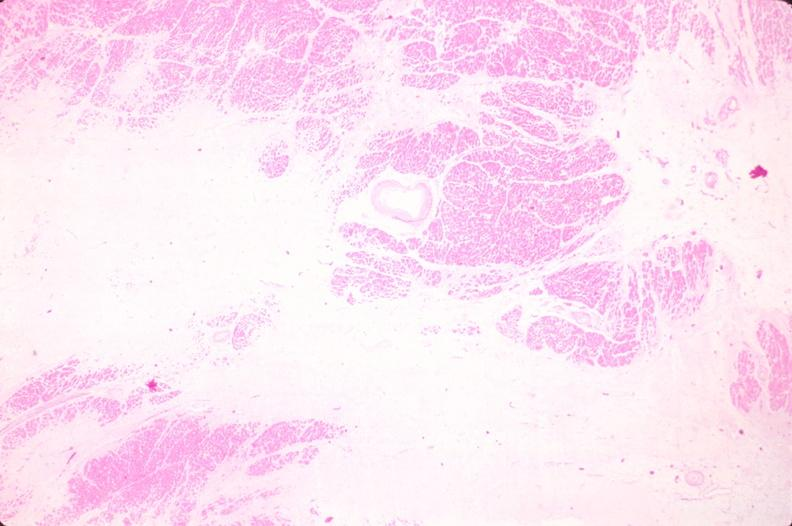s cachexia present?
Answer the question using a single word or phrase. No 